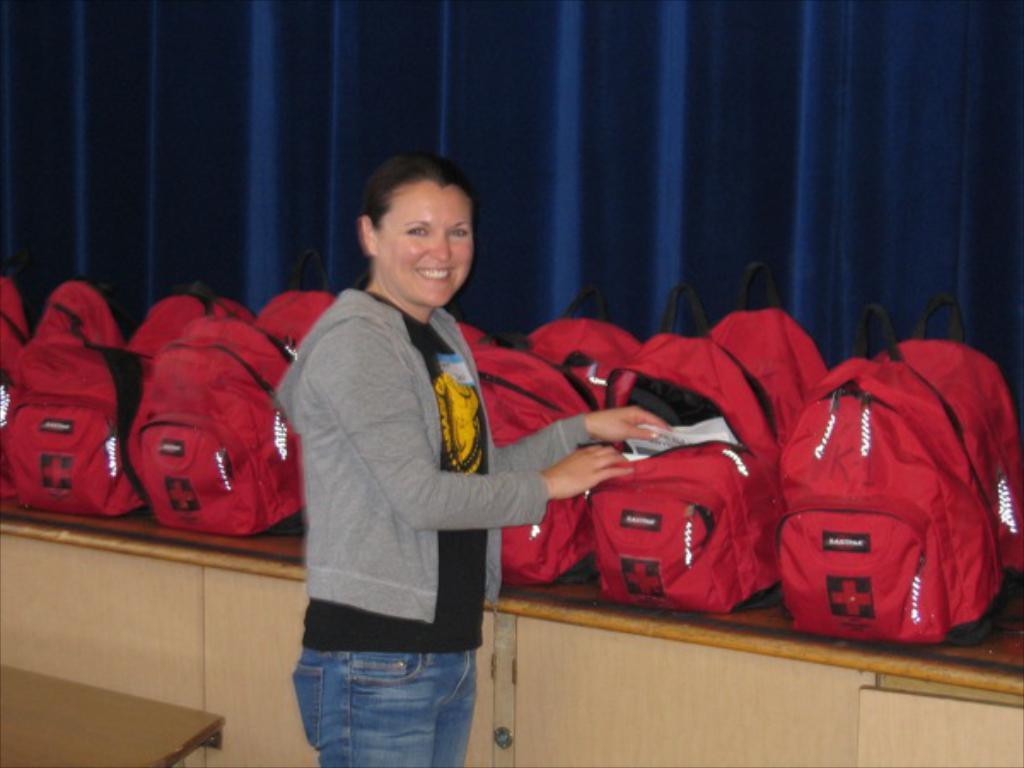Could you give a brief overview of what you see in this image? There is a woman standing at the center and she is smiling. She is looking to open a bag and pickup something from it. In the background there are n number of bags. 